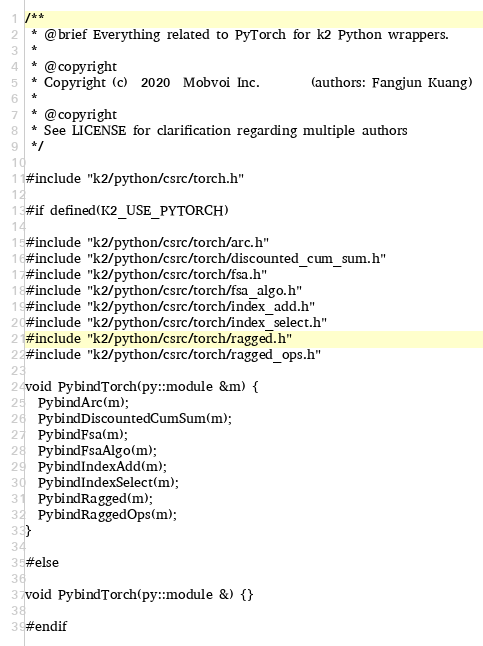Convert code to text. <code><loc_0><loc_0><loc_500><loc_500><_Cuda_>/**
 * @brief Everything related to PyTorch for k2 Python wrappers.
 *
 * @copyright
 * Copyright (c)  2020  Mobvoi Inc.        (authors: Fangjun Kuang)
 *
 * @copyright
 * See LICENSE for clarification regarding multiple authors
 */

#include "k2/python/csrc/torch.h"

#if defined(K2_USE_PYTORCH)

#include "k2/python/csrc/torch/arc.h"
#include "k2/python/csrc/torch/discounted_cum_sum.h"
#include "k2/python/csrc/torch/fsa.h"
#include "k2/python/csrc/torch/fsa_algo.h"
#include "k2/python/csrc/torch/index_add.h"
#include "k2/python/csrc/torch/index_select.h"
#include "k2/python/csrc/torch/ragged.h"
#include "k2/python/csrc/torch/ragged_ops.h"

void PybindTorch(py::module &m) {
  PybindArc(m);
  PybindDiscountedCumSum(m);
  PybindFsa(m);
  PybindFsaAlgo(m);
  PybindIndexAdd(m);
  PybindIndexSelect(m);
  PybindRagged(m);
  PybindRaggedOps(m);
}

#else

void PybindTorch(py::module &) {}

#endif
</code> 